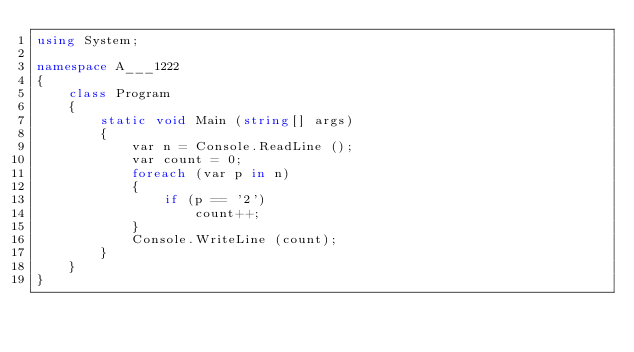<code> <loc_0><loc_0><loc_500><loc_500><_C#_>using System;

namespace A___1222
{
    class Program
    {
        static void Main (string[] args)
        {
            var n = Console.ReadLine ();
            var count = 0;
            foreach (var p in n)
            {
                if (p == '2')
                    count++;
            }
            Console.WriteLine (count);
        }
    }
}</code> 